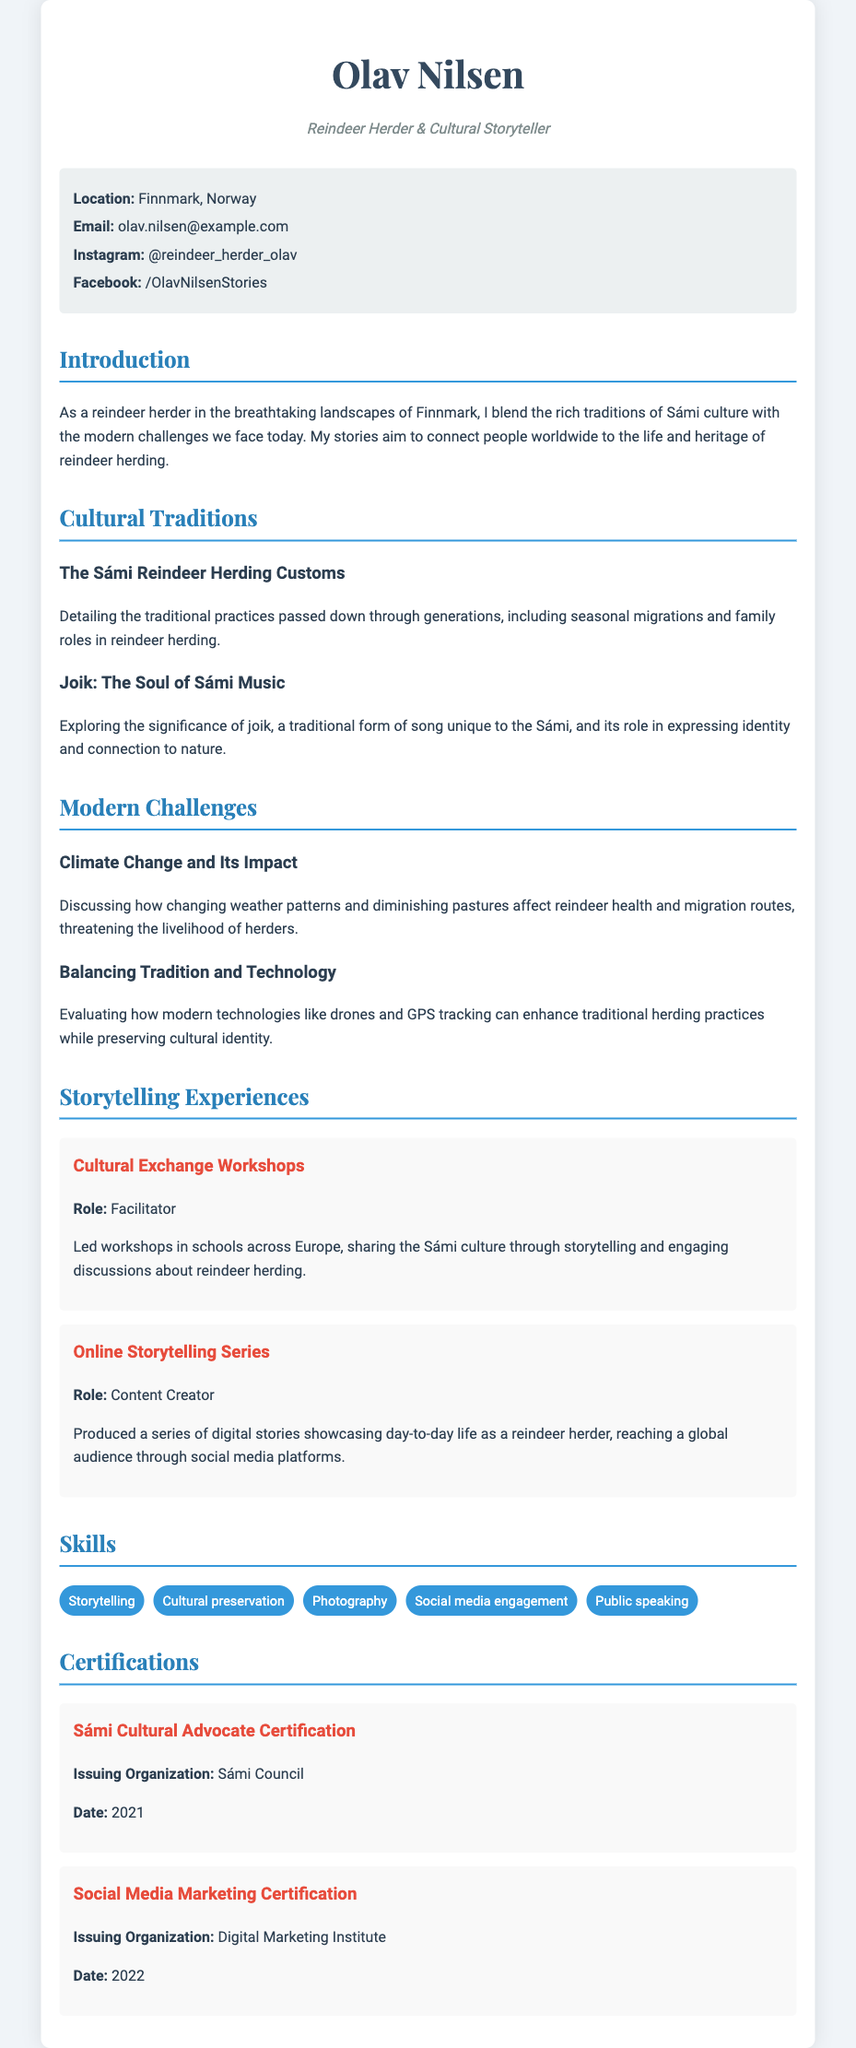what is the name of the reindeer herder? The document clearly states that the reindeer herder's name is Olav Nilsen.
Answer: Olav Nilsen what is Olav Nilsen's role? The document describes Olav Nilsen as a "Reindeer Herder & Cultural Storyteller."
Answer: Reindeer Herder & Cultural Storyteller where is Olav Nilsen located? The location mentioned in the document is Finnmark, Norway.
Answer: Finnmark, Norway what year was the Sámi Cultural Advocate Certification issued? The document specifies that the certification was issued in 2021.
Answer: 2021 what is one of the modern challenges faced by reindeer herders? The document lists several challenges, including climate change impacting reindeer health and migration routes.
Answer: Climate Change how does Olav Nilsen share his stories online? The document mentions that he engages a global audience through social media platforms.
Answer: Social media platforms what is a traditional form of music highlighted in the document? The document notes a traditional form of music known as joik.
Answer: Joik how many storytelling experiences are listed? The document describes two storytelling experiences under the "Storytelling Experiences" section.
Answer: Two what certification is related to social media marketing? The document identifies the "Social Media Marketing Certification" as relevant to this field.
Answer: Social Media Marketing Certification 